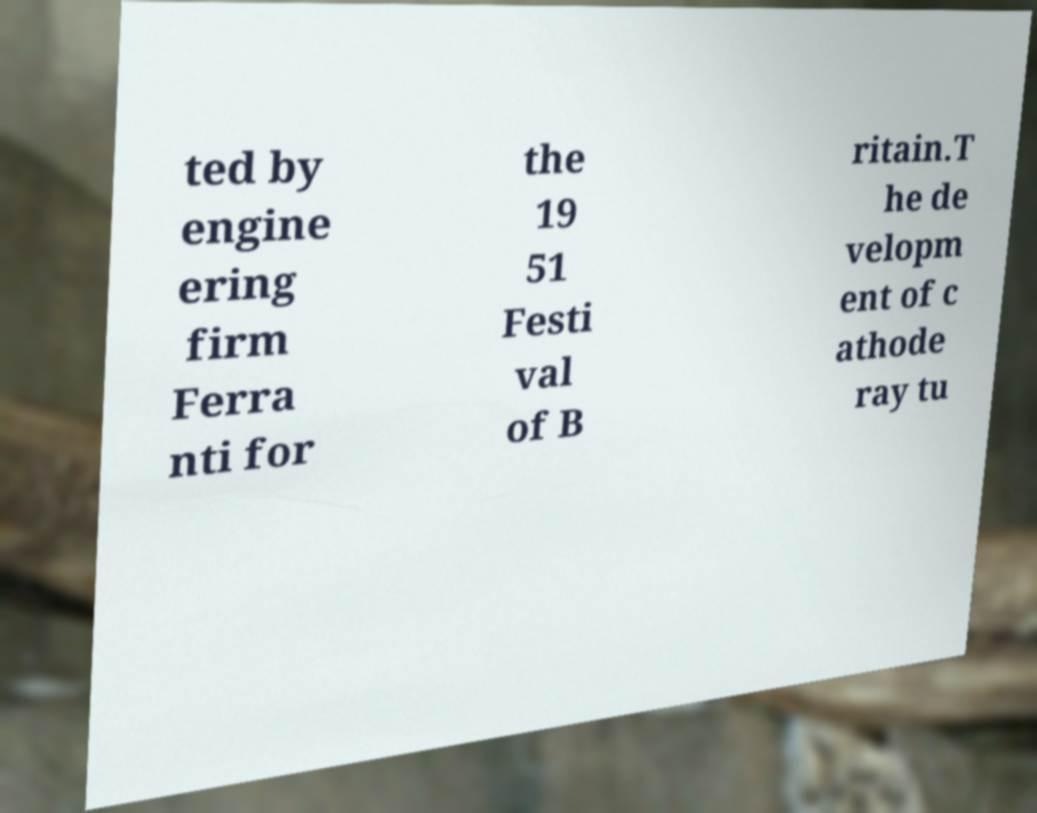What messages or text are displayed in this image? I need them in a readable, typed format. ted by engine ering firm Ferra nti for the 19 51 Festi val of B ritain.T he de velopm ent of c athode ray tu 